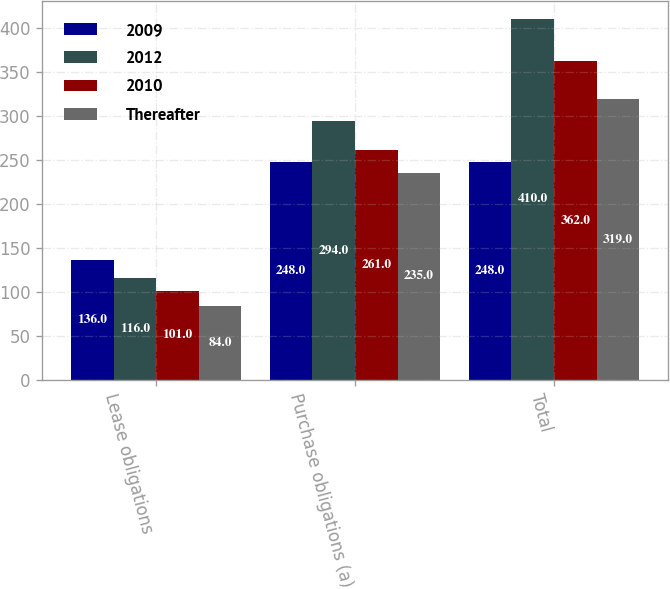<chart> <loc_0><loc_0><loc_500><loc_500><stacked_bar_chart><ecel><fcel>Lease obligations<fcel>Purchase obligations (a)<fcel>Total<nl><fcel>2009<fcel>136<fcel>248<fcel>248<nl><fcel>2012<fcel>116<fcel>294<fcel>410<nl><fcel>2010<fcel>101<fcel>261<fcel>362<nl><fcel>Thereafter<fcel>84<fcel>235<fcel>319<nl></chart> 